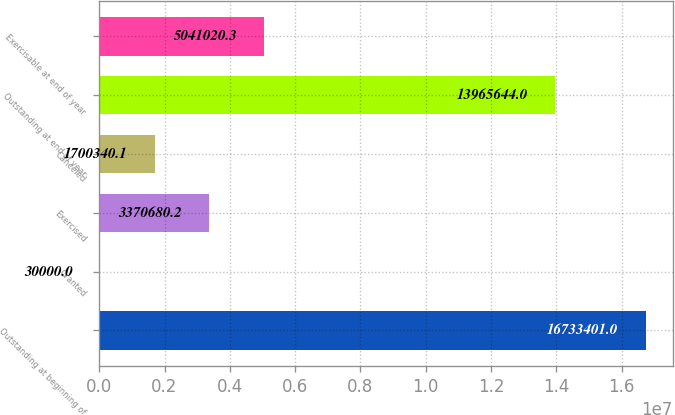<chart> <loc_0><loc_0><loc_500><loc_500><bar_chart><fcel>Outstanding at beginning of<fcel>Granted<fcel>Exercised<fcel>Canceled<fcel>Outstanding at end of year<fcel>Exercisable at end of year<nl><fcel>1.67334e+07<fcel>30000<fcel>3.37068e+06<fcel>1.70034e+06<fcel>1.39656e+07<fcel>5.04102e+06<nl></chart> 